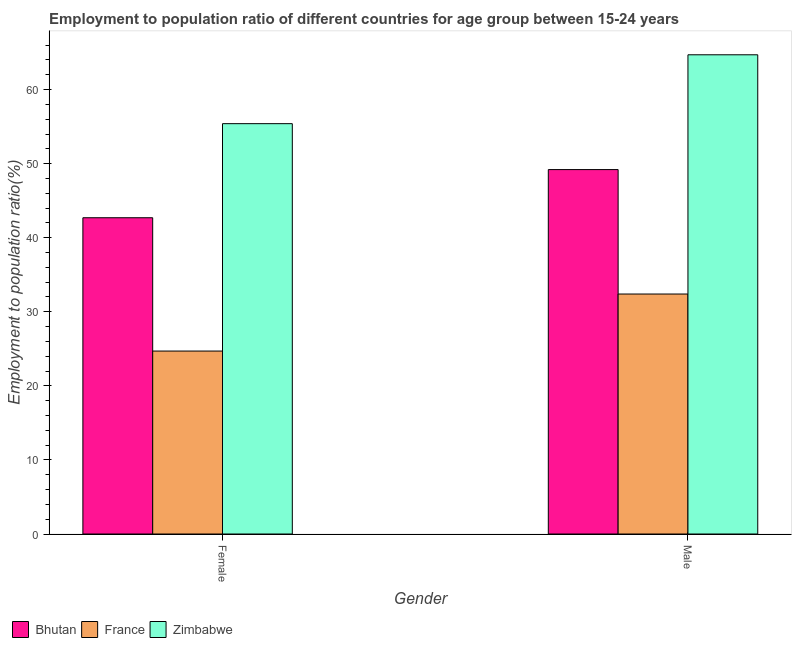How many groups of bars are there?
Offer a terse response. 2. Are the number of bars on each tick of the X-axis equal?
Make the answer very short. Yes. What is the label of the 2nd group of bars from the left?
Offer a terse response. Male. What is the employment to population ratio(female) in France?
Make the answer very short. 24.7. Across all countries, what is the maximum employment to population ratio(male)?
Provide a succinct answer. 64.7. Across all countries, what is the minimum employment to population ratio(female)?
Provide a succinct answer. 24.7. In which country was the employment to population ratio(female) maximum?
Provide a short and direct response. Zimbabwe. In which country was the employment to population ratio(female) minimum?
Your answer should be compact. France. What is the total employment to population ratio(female) in the graph?
Offer a terse response. 122.8. What is the difference between the employment to population ratio(male) in France and that in Zimbabwe?
Your answer should be very brief. -32.3. What is the difference between the employment to population ratio(male) in France and the employment to population ratio(female) in Zimbabwe?
Your answer should be very brief. -23. What is the average employment to population ratio(male) per country?
Your response must be concise. 48.77. What is the difference between the employment to population ratio(female) and employment to population ratio(male) in France?
Make the answer very short. -7.7. What is the ratio of the employment to population ratio(female) in Bhutan to that in France?
Offer a very short reply. 1.73. In how many countries, is the employment to population ratio(female) greater than the average employment to population ratio(female) taken over all countries?
Provide a succinct answer. 2. What does the 1st bar from the left in Female represents?
Keep it short and to the point. Bhutan. What does the 3rd bar from the right in Male represents?
Your response must be concise. Bhutan. How many bars are there?
Offer a very short reply. 6. Are all the bars in the graph horizontal?
Your response must be concise. No. How many countries are there in the graph?
Keep it short and to the point. 3. Does the graph contain any zero values?
Provide a succinct answer. No. Does the graph contain grids?
Provide a succinct answer. No. How are the legend labels stacked?
Make the answer very short. Horizontal. What is the title of the graph?
Keep it short and to the point. Employment to population ratio of different countries for age group between 15-24 years. What is the label or title of the X-axis?
Keep it short and to the point. Gender. What is the Employment to population ratio(%) in Bhutan in Female?
Give a very brief answer. 42.7. What is the Employment to population ratio(%) in France in Female?
Your response must be concise. 24.7. What is the Employment to population ratio(%) of Zimbabwe in Female?
Make the answer very short. 55.4. What is the Employment to population ratio(%) of Bhutan in Male?
Offer a very short reply. 49.2. What is the Employment to population ratio(%) in France in Male?
Your response must be concise. 32.4. What is the Employment to population ratio(%) of Zimbabwe in Male?
Keep it short and to the point. 64.7. Across all Gender, what is the maximum Employment to population ratio(%) of Bhutan?
Ensure brevity in your answer.  49.2. Across all Gender, what is the maximum Employment to population ratio(%) in France?
Make the answer very short. 32.4. Across all Gender, what is the maximum Employment to population ratio(%) of Zimbabwe?
Make the answer very short. 64.7. Across all Gender, what is the minimum Employment to population ratio(%) of Bhutan?
Ensure brevity in your answer.  42.7. Across all Gender, what is the minimum Employment to population ratio(%) in France?
Offer a very short reply. 24.7. Across all Gender, what is the minimum Employment to population ratio(%) in Zimbabwe?
Your response must be concise. 55.4. What is the total Employment to population ratio(%) of Bhutan in the graph?
Your answer should be compact. 91.9. What is the total Employment to population ratio(%) in France in the graph?
Provide a succinct answer. 57.1. What is the total Employment to population ratio(%) of Zimbabwe in the graph?
Your response must be concise. 120.1. What is the difference between the Employment to population ratio(%) in Bhutan in Female and that in Male?
Your answer should be compact. -6.5. What is the difference between the Employment to population ratio(%) of France in Female and that in Male?
Offer a very short reply. -7.7. What is the difference between the Employment to population ratio(%) in Zimbabwe in Female and that in Male?
Provide a short and direct response. -9.3. What is the difference between the Employment to population ratio(%) in France in Female and the Employment to population ratio(%) in Zimbabwe in Male?
Provide a succinct answer. -40. What is the average Employment to population ratio(%) in Bhutan per Gender?
Keep it short and to the point. 45.95. What is the average Employment to population ratio(%) in France per Gender?
Offer a very short reply. 28.55. What is the average Employment to population ratio(%) in Zimbabwe per Gender?
Provide a succinct answer. 60.05. What is the difference between the Employment to population ratio(%) in France and Employment to population ratio(%) in Zimbabwe in Female?
Offer a terse response. -30.7. What is the difference between the Employment to population ratio(%) in Bhutan and Employment to population ratio(%) in Zimbabwe in Male?
Give a very brief answer. -15.5. What is the difference between the Employment to population ratio(%) of France and Employment to population ratio(%) of Zimbabwe in Male?
Your answer should be compact. -32.3. What is the ratio of the Employment to population ratio(%) in Bhutan in Female to that in Male?
Your answer should be compact. 0.87. What is the ratio of the Employment to population ratio(%) of France in Female to that in Male?
Offer a very short reply. 0.76. What is the ratio of the Employment to population ratio(%) of Zimbabwe in Female to that in Male?
Offer a very short reply. 0.86. What is the difference between the highest and the second highest Employment to population ratio(%) in France?
Make the answer very short. 7.7. What is the difference between the highest and the second highest Employment to population ratio(%) of Zimbabwe?
Offer a very short reply. 9.3. What is the difference between the highest and the lowest Employment to population ratio(%) of Bhutan?
Keep it short and to the point. 6.5. 